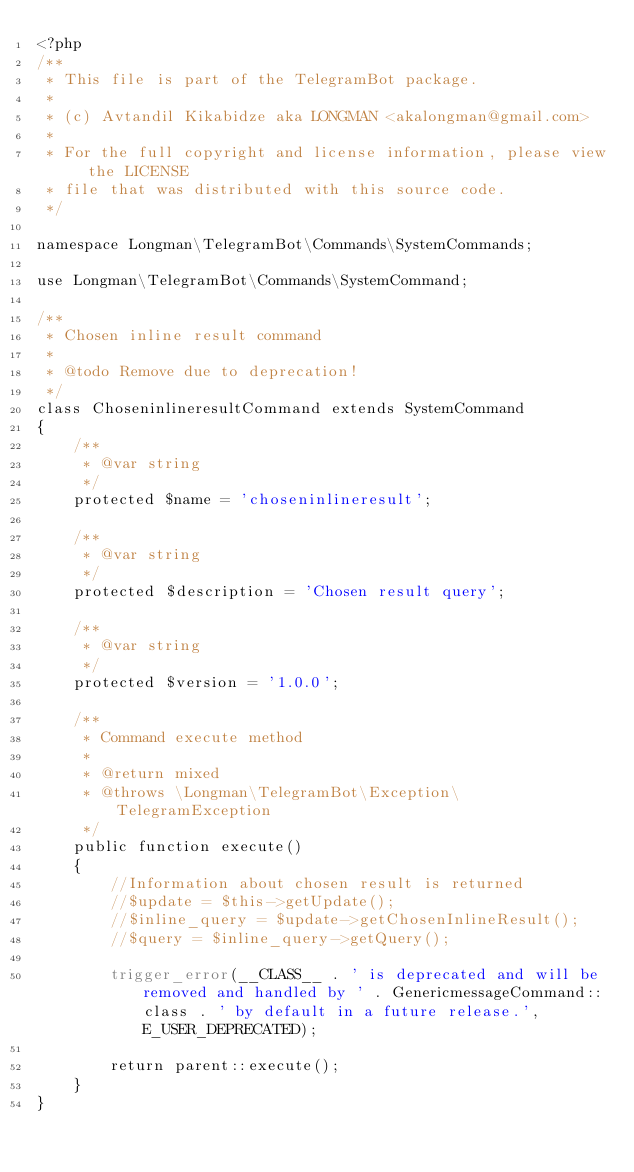Convert code to text. <code><loc_0><loc_0><loc_500><loc_500><_PHP_><?php
/**
 * This file is part of the TelegramBot package.
 *
 * (c) Avtandil Kikabidze aka LONGMAN <akalongman@gmail.com>
 *
 * For the full copyright and license information, please view the LICENSE
 * file that was distributed with this source code.
 */

namespace Longman\TelegramBot\Commands\SystemCommands;

use Longman\TelegramBot\Commands\SystemCommand;

/**
 * Chosen inline result command
 *
 * @todo Remove due to deprecation!
 */
class ChoseninlineresultCommand extends SystemCommand
{
    /**
     * @var string
     */
    protected $name = 'choseninlineresult';

    /**
     * @var string
     */
    protected $description = 'Chosen result query';

    /**
     * @var string
     */
    protected $version = '1.0.0';

    /**
     * Command execute method
     *
     * @return mixed
     * @throws \Longman\TelegramBot\Exception\TelegramException
     */
    public function execute()
    {
        //Information about chosen result is returned
        //$update = $this->getUpdate();
        //$inline_query = $update->getChosenInlineResult();
        //$query = $inline_query->getQuery();

        trigger_error(__CLASS__ . ' is deprecated and will be removed and handled by ' . GenericmessageCommand::class . ' by default in a future release.', E_USER_DEPRECATED);

        return parent::execute();
    }
}
</code> 